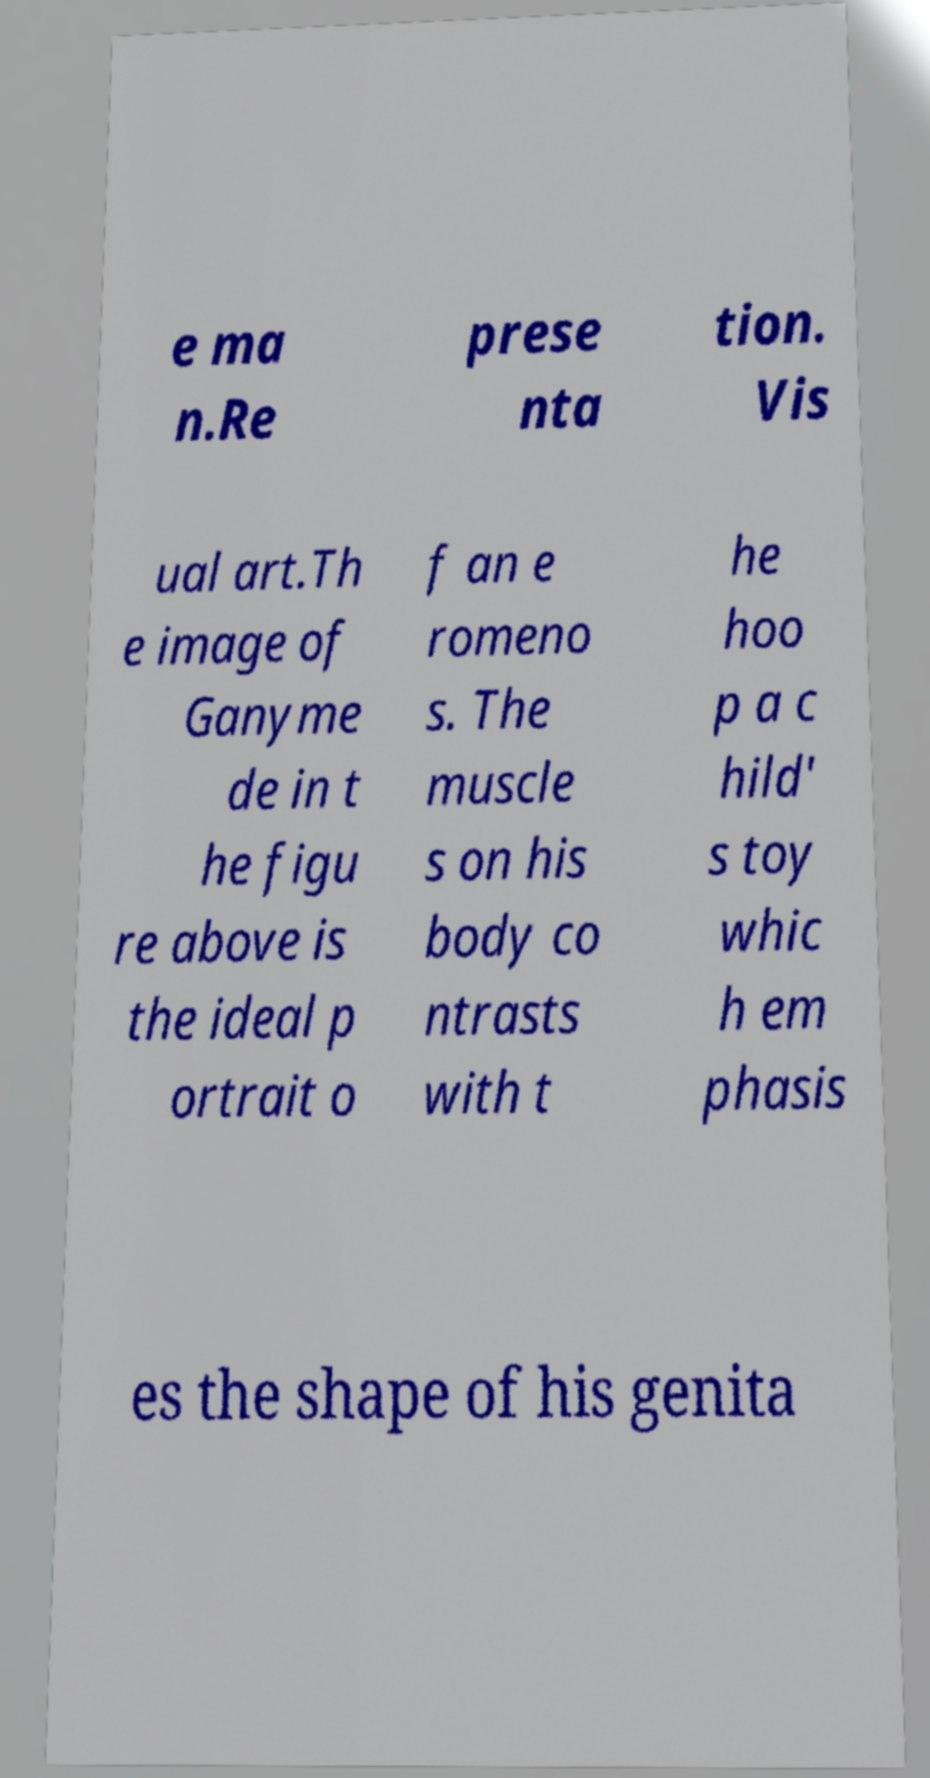Please read and relay the text visible in this image. What does it say? e ma n.Re prese nta tion. Vis ual art.Th e image of Ganyme de in t he figu re above is the ideal p ortrait o f an e romeno s. The muscle s on his body co ntrasts with t he hoo p a c hild' s toy whic h em phasis es the shape of his genita 